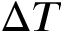Convert formula to latex. <formula><loc_0><loc_0><loc_500><loc_500>\Delta T</formula> 